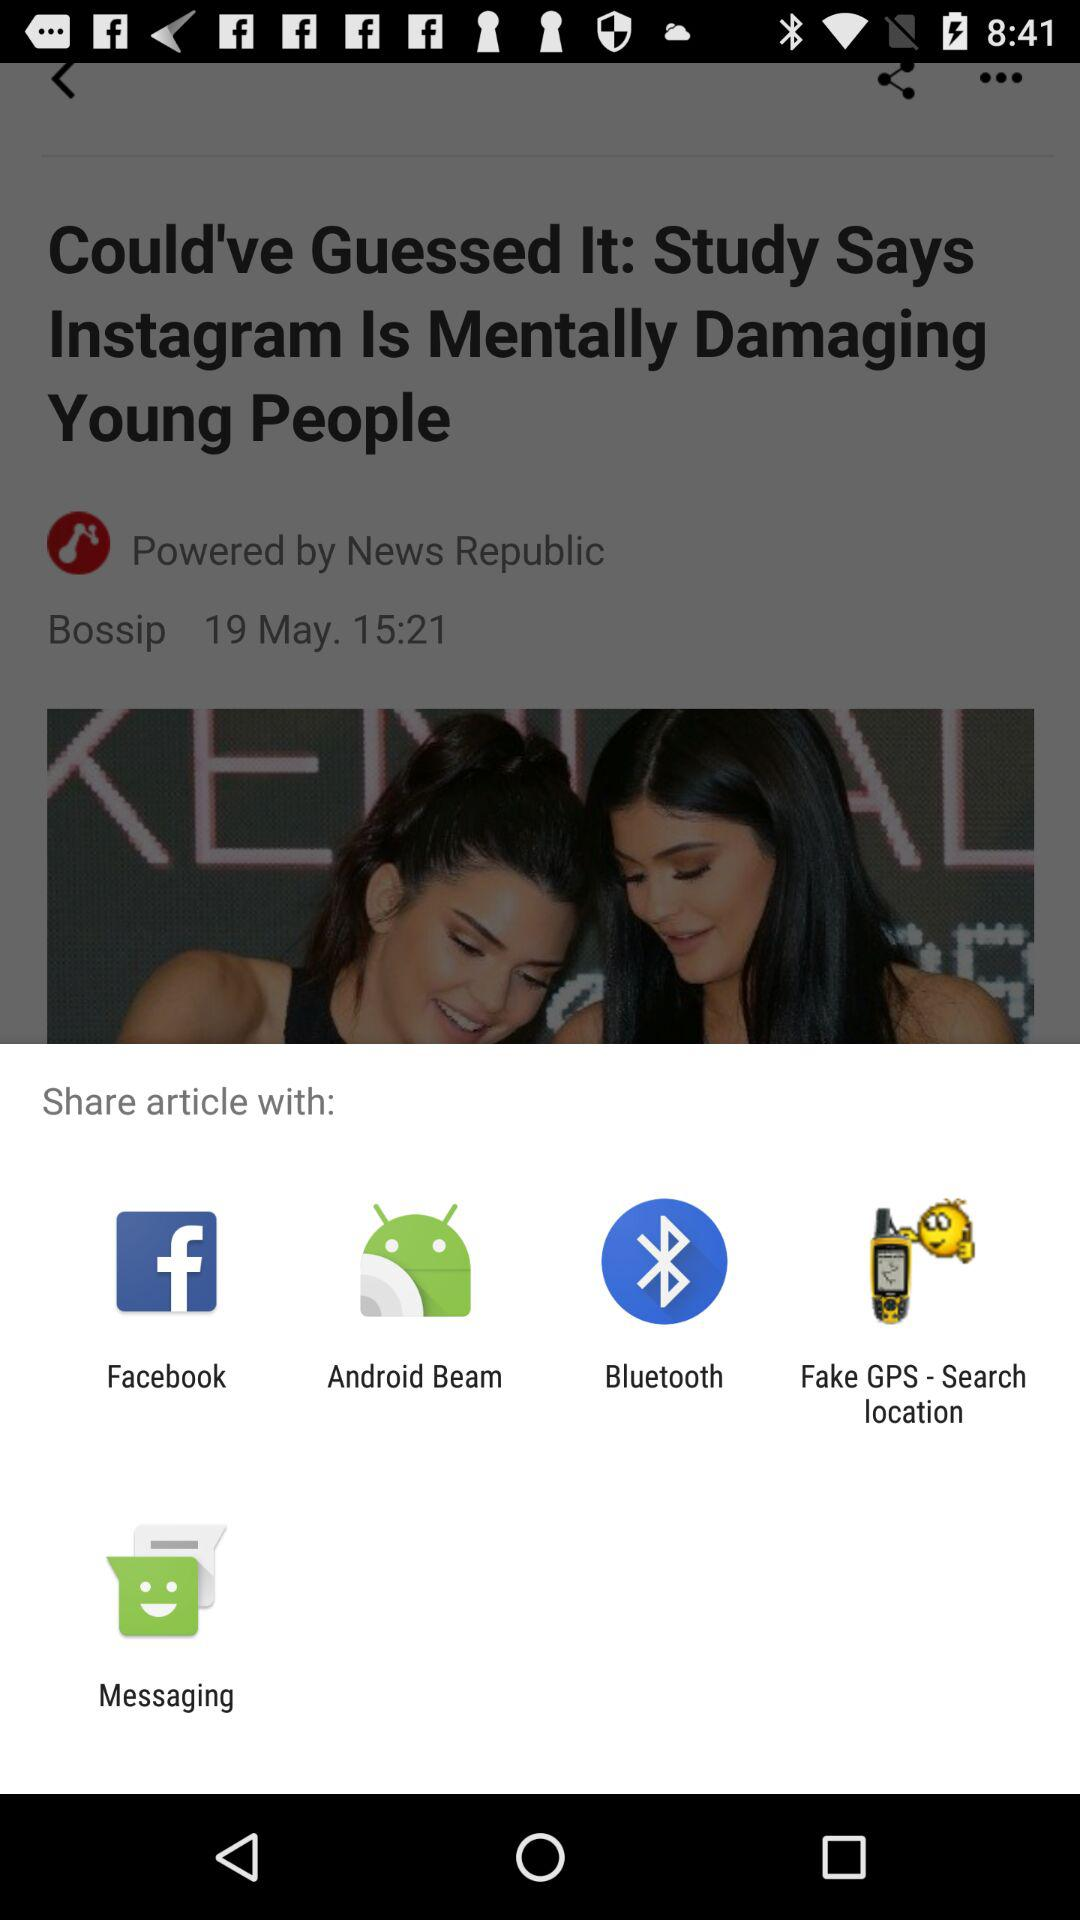Through which application can be shared? You can share it with "Facebook", "Android Beam", "Bluetooth", "Fake GPS - Search location" and "Messaging". 